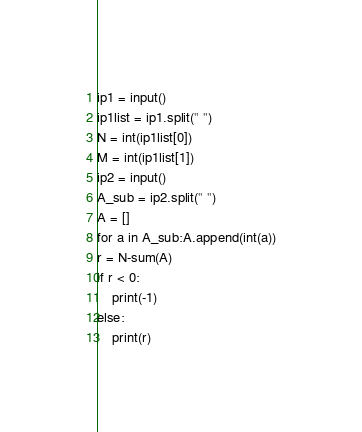Convert code to text. <code><loc_0><loc_0><loc_500><loc_500><_Python_>ip1 = input()
ip1list = ip1.split(" ")
N = int(ip1list[0])
M = int(ip1list[1])
ip2 = input()
A_sub = ip2.split(" ")
A = []
for a in A_sub:A.append(int(a))
r = N-sum(A)
if r < 0:
    print(-1)
else:
    print(r)</code> 